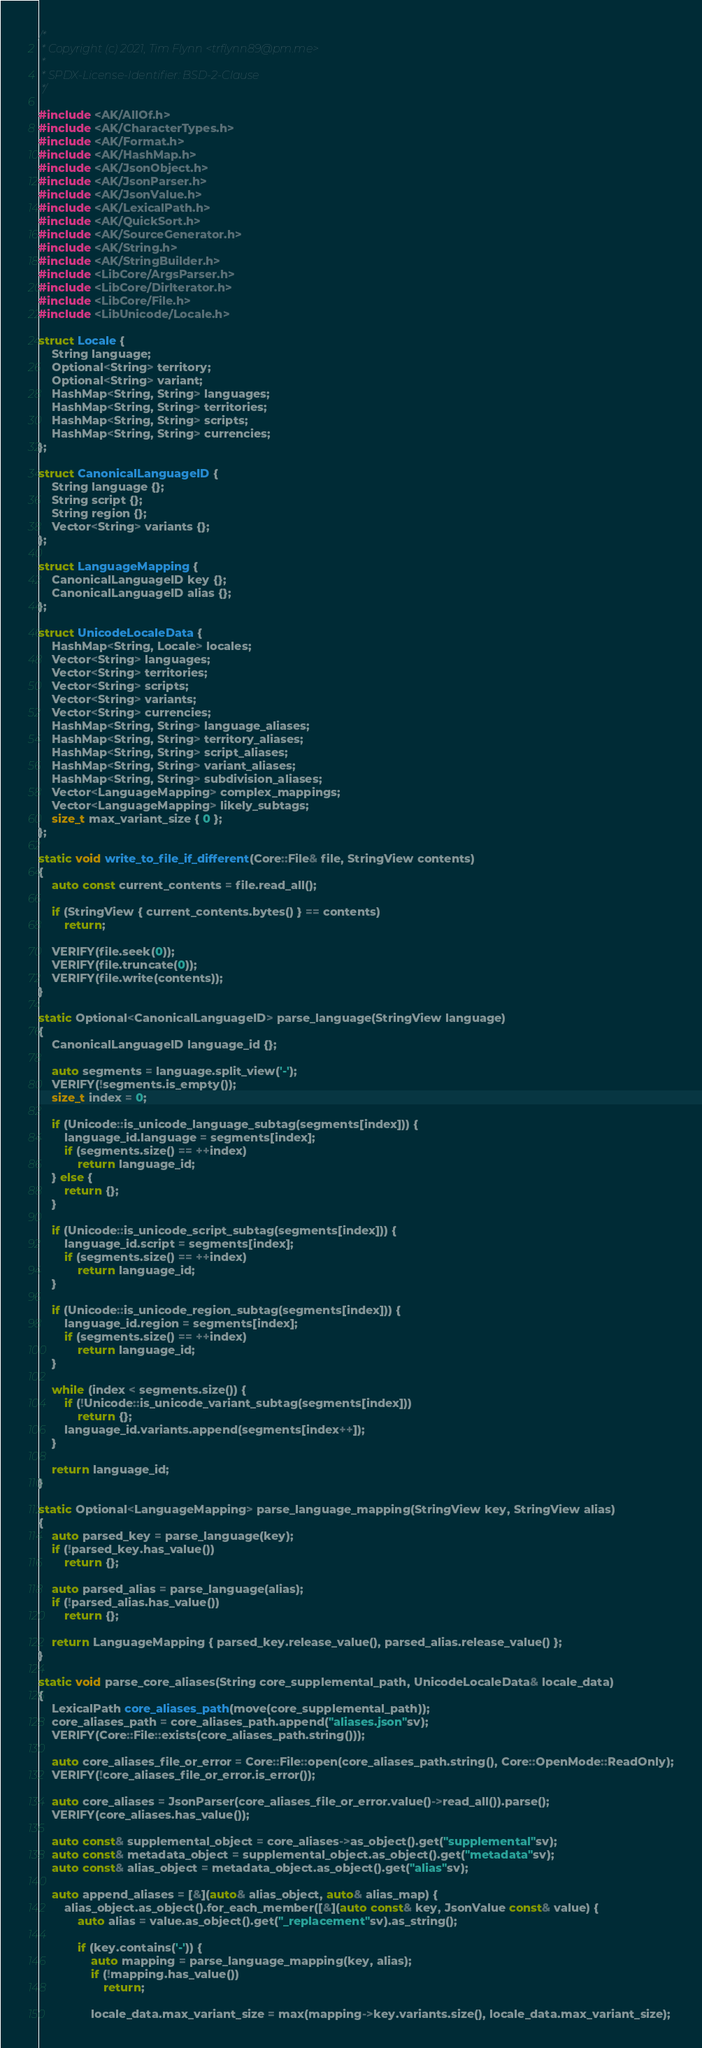Convert code to text. <code><loc_0><loc_0><loc_500><loc_500><_C++_>/*
 * Copyright (c) 2021, Tim Flynn <trflynn89@pm.me>
 *
 * SPDX-License-Identifier: BSD-2-Clause
 */

#include <AK/AllOf.h>
#include <AK/CharacterTypes.h>
#include <AK/Format.h>
#include <AK/HashMap.h>
#include <AK/JsonObject.h>
#include <AK/JsonParser.h>
#include <AK/JsonValue.h>
#include <AK/LexicalPath.h>
#include <AK/QuickSort.h>
#include <AK/SourceGenerator.h>
#include <AK/String.h>
#include <AK/StringBuilder.h>
#include <LibCore/ArgsParser.h>
#include <LibCore/DirIterator.h>
#include <LibCore/File.h>
#include <LibUnicode/Locale.h>

struct Locale {
    String language;
    Optional<String> territory;
    Optional<String> variant;
    HashMap<String, String> languages;
    HashMap<String, String> territories;
    HashMap<String, String> scripts;
    HashMap<String, String> currencies;
};

struct CanonicalLanguageID {
    String language {};
    String script {};
    String region {};
    Vector<String> variants {};
};

struct LanguageMapping {
    CanonicalLanguageID key {};
    CanonicalLanguageID alias {};
};

struct UnicodeLocaleData {
    HashMap<String, Locale> locales;
    Vector<String> languages;
    Vector<String> territories;
    Vector<String> scripts;
    Vector<String> variants;
    Vector<String> currencies;
    HashMap<String, String> language_aliases;
    HashMap<String, String> territory_aliases;
    HashMap<String, String> script_aliases;
    HashMap<String, String> variant_aliases;
    HashMap<String, String> subdivision_aliases;
    Vector<LanguageMapping> complex_mappings;
    Vector<LanguageMapping> likely_subtags;
    size_t max_variant_size { 0 };
};

static void write_to_file_if_different(Core::File& file, StringView contents)
{
    auto const current_contents = file.read_all();

    if (StringView { current_contents.bytes() } == contents)
        return;

    VERIFY(file.seek(0));
    VERIFY(file.truncate(0));
    VERIFY(file.write(contents));
}

static Optional<CanonicalLanguageID> parse_language(StringView language)
{
    CanonicalLanguageID language_id {};

    auto segments = language.split_view('-');
    VERIFY(!segments.is_empty());
    size_t index = 0;

    if (Unicode::is_unicode_language_subtag(segments[index])) {
        language_id.language = segments[index];
        if (segments.size() == ++index)
            return language_id;
    } else {
        return {};
    }

    if (Unicode::is_unicode_script_subtag(segments[index])) {
        language_id.script = segments[index];
        if (segments.size() == ++index)
            return language_id;
    }

    if (Unicode::is_unicode_region_subtag(segments[index])) {
        language_id.region = segments[index];
        if (segments.size() == ++index)
            return language_id;
    }

    while (index < segments.size()) {
        if (!Unicode::is_unicode_variant_subtag(segments[index]))
            return {};
        language_id.variants.append(segments[index++]);
    }

    return language_id;
}

static Optional<LanguageMapping> parse_language_mapping(StringView key, StringView alias)
{
    auto parsed_key = parse_language(key);
    if (!parsed_key.has_value())
        return {};

    auto parsed_alias = parse_language(alias);
    if (!parsed_alias.has_value())
        return {};

    return LanguageMapping { parsed_key.release_value(), parsed_alias.release_value() };
}

static void parse_core_aliases(String core_supplemental_path, UnicodeLocaleData& locale_data)
{
    LexicalPath core_aliases_path(move(core_supplemental_path));
    core_aliases_path = core_aliases_path.append("aliases.json"sv);
    VERIFY(Core::File::exists(core_aliases_path.string()));

    auto core_aliases_file_or_error = Core::File::open(core_aliases_path.string(), Core::OpenMode::ReadOnly);
    VERIFY(!core_aliases_file_or_error.is_error());

    auto core_aliases = JsonParser(core_aliases_file_or_error.value()->read_all()).parse();
    VERIFY(core_aliases.has_value());

    auto const& supplemental_object = core_aliases->as_object().get("supplemental"sv);
    auto const& metadata_object = supplemental_object.as_object().get("metadata"sv);
    auto const& alias_object = metadata_object.as_object().get("alias"sv);

    auto append_aliases = [&](auto& alias_object, auto& alias_map) {
        alias_object.as_object().for_each_member([&](auto const& key, JsonValue const& value) {
            auto alias = value.as_object().get("_replacement"sv).as_string();

            if (key.contains('-')) {
                auto mapping = parse_language_mapping(key, alias);
                if (!mapping.has_value())
                    return;

                locale_data.max_variant_size = max(mapping->key.variants.size(), locale_data.max_variant_size);</code> 